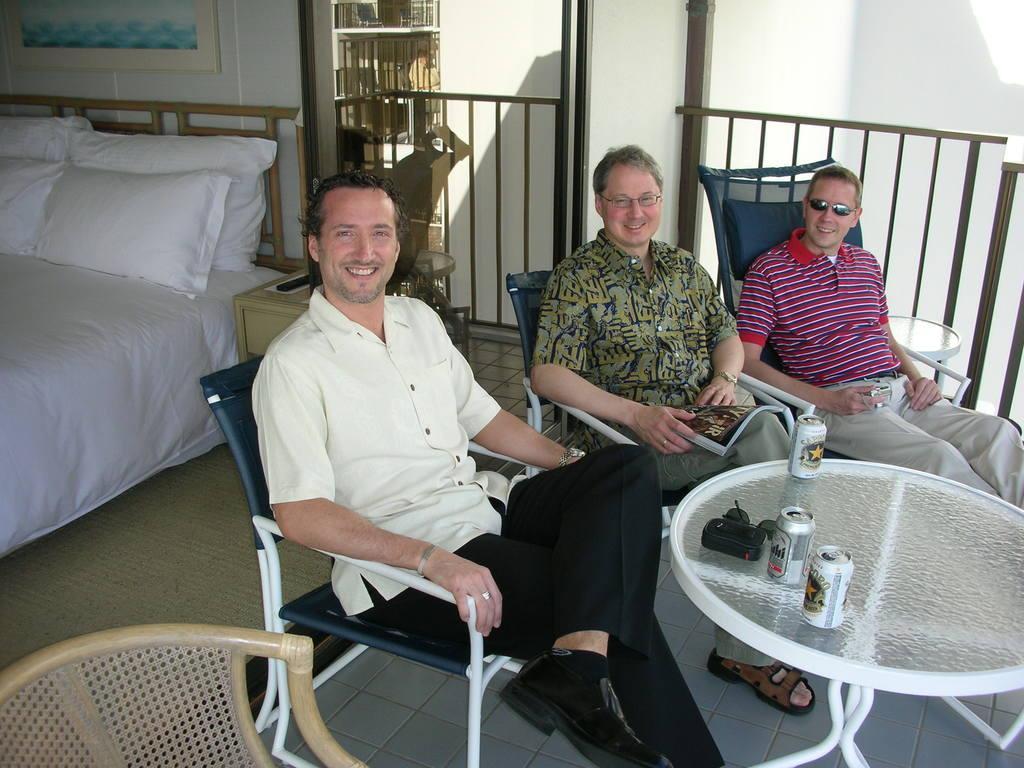Describe this image in one or two sentences. In this image i can see 3 persons sitting on chairs in front of a table, On the table i can see three things, a sun glass and few other objects. The person sitting in the middle is holding a book. In the background i can see a bed, few pillows, the wall and the photo frame. 